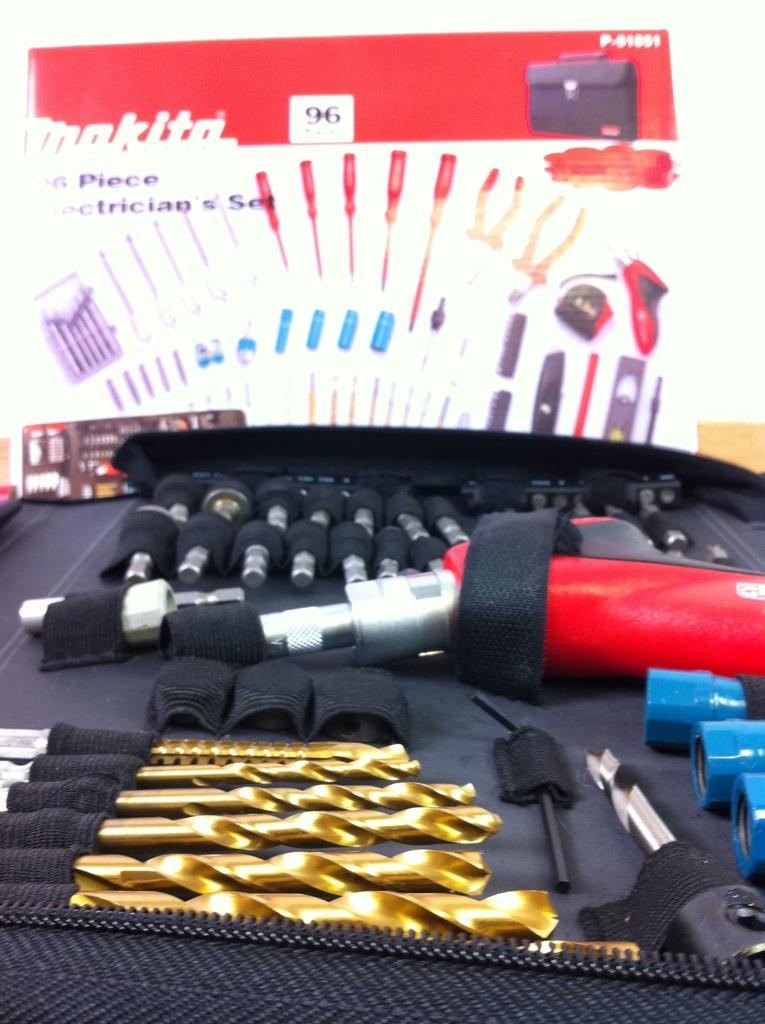Can you describe this image briefly? In this image we can see drilling kit and its carton in the background. 